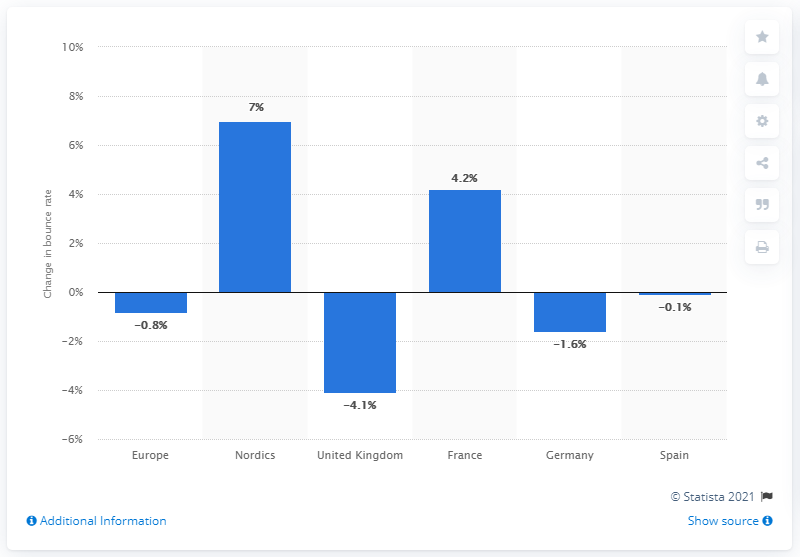Draw attention to some important aspects in this diagram. The bounce rate in the northern European region increased by 7%. The increase in bounce rates in France was 4.2%. 